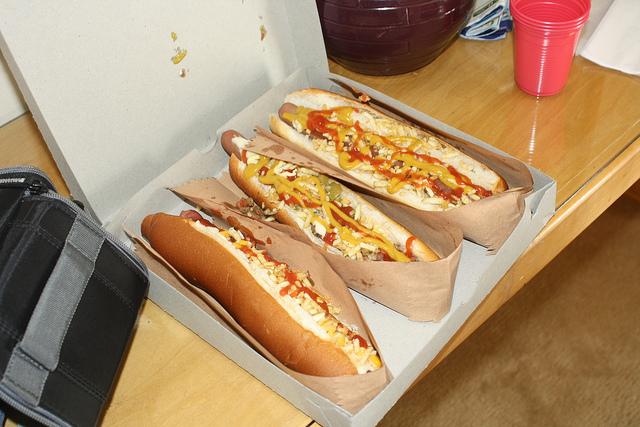What kind of cups are they going to use?
Concise answer only. Plastic. Is there pizza in the box?
Short answer required. No. Would a vegetarian eat these?
Concise answer only. No. Is this edible?
Give a very brief answer. Yes. Is the glass full of water?
Write a very short answer. No. 